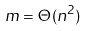Convert formula to latex. <formula><loc_0><loc_0><loc_500><loc_500>m = \Theta ( n ^ { 2 } )</formula> 